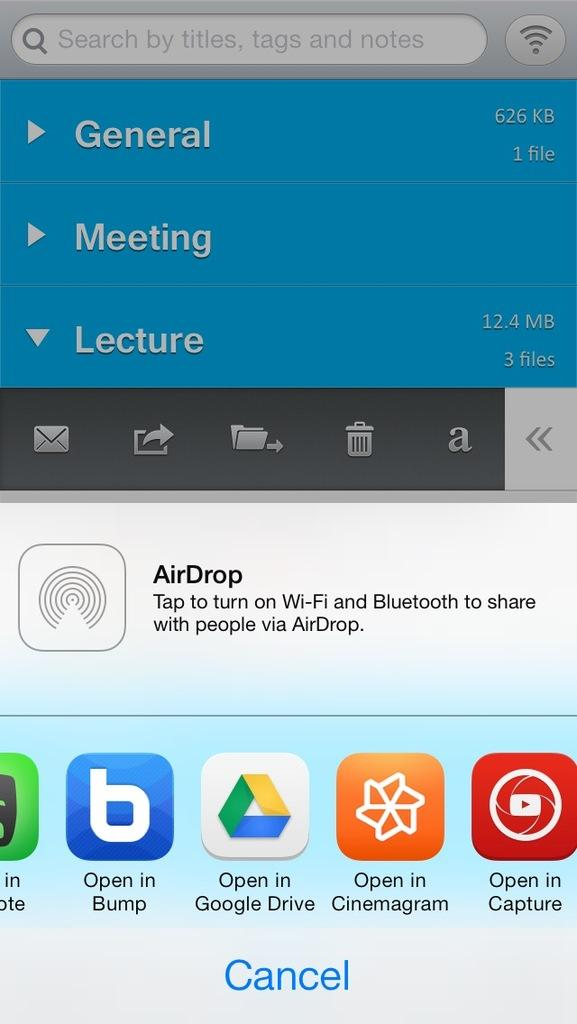<image>
Present a compact description of the photo's key features. A web page showing google drive and Cinemagram. 